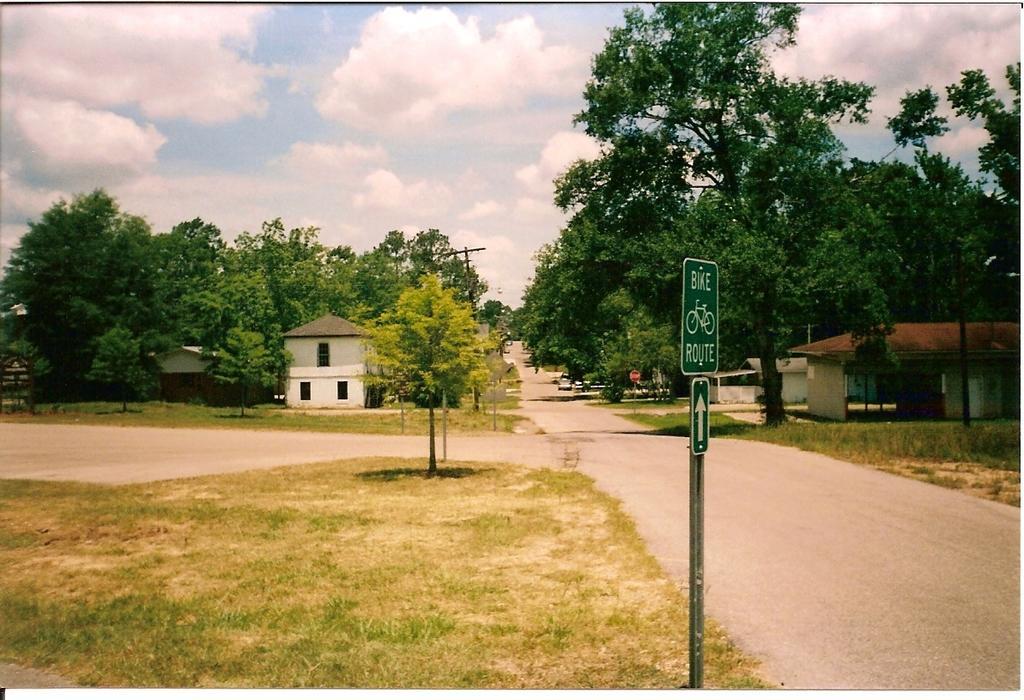Please provide a concise description of this image. In this image I can see a board, light poles, grass, plants, trees, houses, windows, fleets of vehicles on the road and a group of people. In the background I can see the sky. This image is taken may be during a day. 